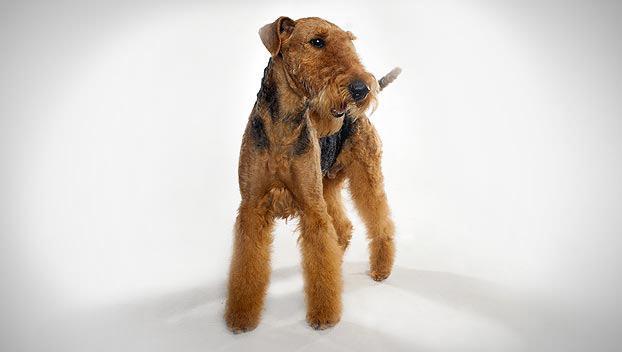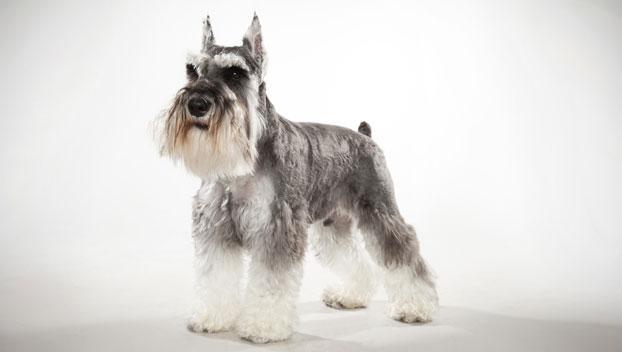The first image is the image on the left, the second image is the image on the right. Examine the images to the left and right. Is the description "The left image shows a schnauzer sitting upright." accurate? Answer yes or no. No. 